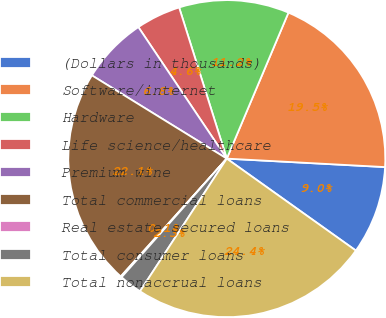Convert chart. <chart><loc_0><loc_0><loc_500><loc_500><pie_chart><fcel>(Dollars in thousands)<fcel>Software/internet<fcel>Hardware<fcel>Life science/healthcare<fcel>Premium wine<fcel>Total commercial loans<fcel>Real estate secured loans<fcel>Total consumer loans<fcel>Total nonaccrual loans<nl><fcel>9.0%<fcel>19.49%<fcel>11.22%<fcel>4.56%<fcel>6.78%<fcel>22.14%<fcel>0.11%<fcel>2.33%<fcel>24.37%<nl></chart> 